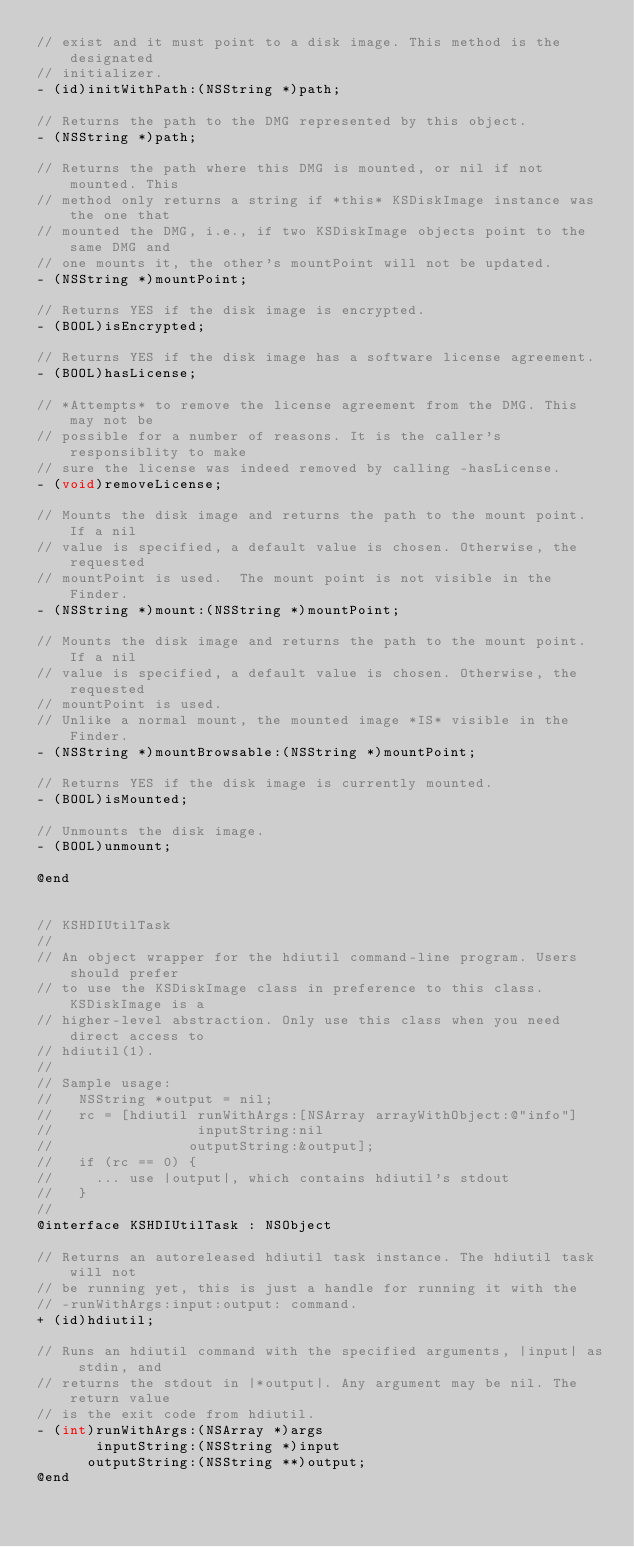<code> <loc_0><loc_0><loc_500><loc_500><_C_>// exist and it must point to a disk image. This method is the designated
// initializer.
- (id)initWithPath:(NSString *)path;

// Returns the path to the DMG represented by this object.
- (NSString *)path;

// Returns the path where this DMG is mounted, or nil if not mounted. This
// method only returns a string if *this* KSDiskImage instance was the one that
// mounted the DMG, i.e., if two KSDiskImage objects point to the same DMG and
// one mounts it, the other's mountPoint will not be updated.
- (NSString *)mountPoint;

// Returns YES if the disk image is encrypted.
- (BOOL)isEncrypted;

// Returns YES if the disk image has a software license agreement.
- (BOOL)hasLicense;

// *Attempts* to remove the license agreement from the DMG. This may not be
// possible for a number of reasons. It is the caller's responsiblity to make
// sure the license was indeed removed by calling -hasLicense.
- (void)removeLicense;

// Mounts the disk image and returns the path to the mount point. If a nil
// value is specified, a default value is chosen. Otherwise, the requested
// mountPoint is used.  The mount point is not visible in the Finder.
- (NSString *)mount:(NSString *)mountPoint;

// Mounts the disk image and returns the path to the mount point. If a nil
// value is specified, a default value is chosen. Otherwise, the requested
// mountPoint is used.
// Unlike a normal mount, the mounted image *IS* visible in the Finder.
- (NSString *)mountBrowsable:(NSString *)mountPoint;

// Returns YES if the disk image is currently mounted.
- (BOOL)isMounted;

// Unmounts the disk image.
- (BOOL)unmount;

@end


// KSHDIUtilTask
//
// An object wrapper for the hdiutil command-line program. Users should prefer
// to use the KSDiskImage class in preference to this class. KSDiskImage is a
// higher-level abstraction. Only use this class when you need direct access to
// hdiutil(1).
//
// Sample usage:
//   NSString *output = nil;
//   rc = [hdiutil runWithArgs:[NSArray arrayWithObject:@"info"]
//                 inputString:nil
//                outputString:&output];
//   if (rc == 0) {
//     ... use |output|, which contains hdiutil's stdout
//   }
//
@interface KSHDIUtilTask : NSObject

// Returns an autoreleased hdiutil task instance. The hdiutil task will not
// be running yet, this is just a handle for running it with the
// -runWithArgs:input:output: command.
+ (id)hdiutil;

// Runs an hdiutil command with the specified arguments, |input| as stdin, and
// returns the stdout in |*output|. Any argument may be nil. The return value
// is the exit code from hdiutil.
- (int)runWithArgs:(NSArray *)args
       inputString:(NSString *)input
      outputString:(NSString **)output;
@end
</code> 